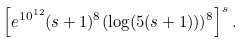Convert formula to latex. <formula><loc_0><loc_0><loc_500><loc_500>\left [ e ^ { 1 0 ^ { 1 2 } } ( s + 1 ) ^ { 8 } ( \log ( 5 ( s + 1 ) ) ) ^ { 8 } \right ] ^ { s } .</formula> 